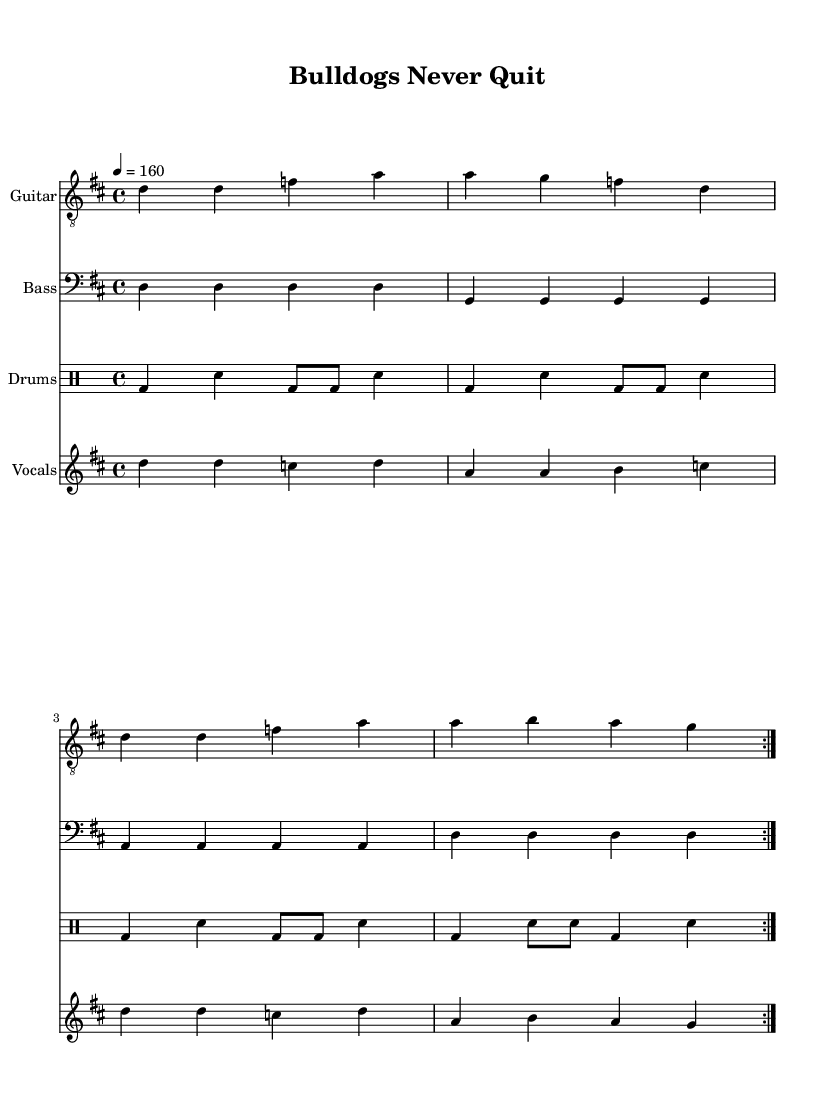What is the key signature of this music? The key signature is represented at the beginning of the score. It shows two sharps, which indicates the key of D major.
Answer: D major What is the time signature of this music? The time signature is indicated near the beginning of the score and reads 4 over 4, which means four beats in a measure and the quarter note gets one beat.
Answer: 4/4 What is the tempo marking for this piece? The tempo marking is indicated at the beginning of the score with a metronomic number. It shows 4 equals 160, which means the quarter note is played at 160 beats per minute.
Answer: 160 How many measures are repeated in the score? The score indicates a repeat section for both the guitar and drums, which shows that there are 2 measures that are stated to be repeated.
Answer: 2 What genre does this music belong to? Although this specific piece of music does not have a genre labeled, the wording in the lyrics, along with the instrumentation and style, suggests it is characteristic of a punk anthem about teamwork and perseverance in sports.
Answer: Punk What do the lyrics promote? The lyrics as a whole emphasize themes of unity and determination, particularly through phrases that illustrate fighting together and not giving up, which fits the context of sports teamwork.
Answer: Teamwork and perseverance What is the main message of the chorus? The chorus has a clear message that emphasizes resilience and dedication, calling for unity and strength against challenges, which is encapsulated in the lines that state, "Bull dogs never quit, we stand as one."
Answer: Resilience 